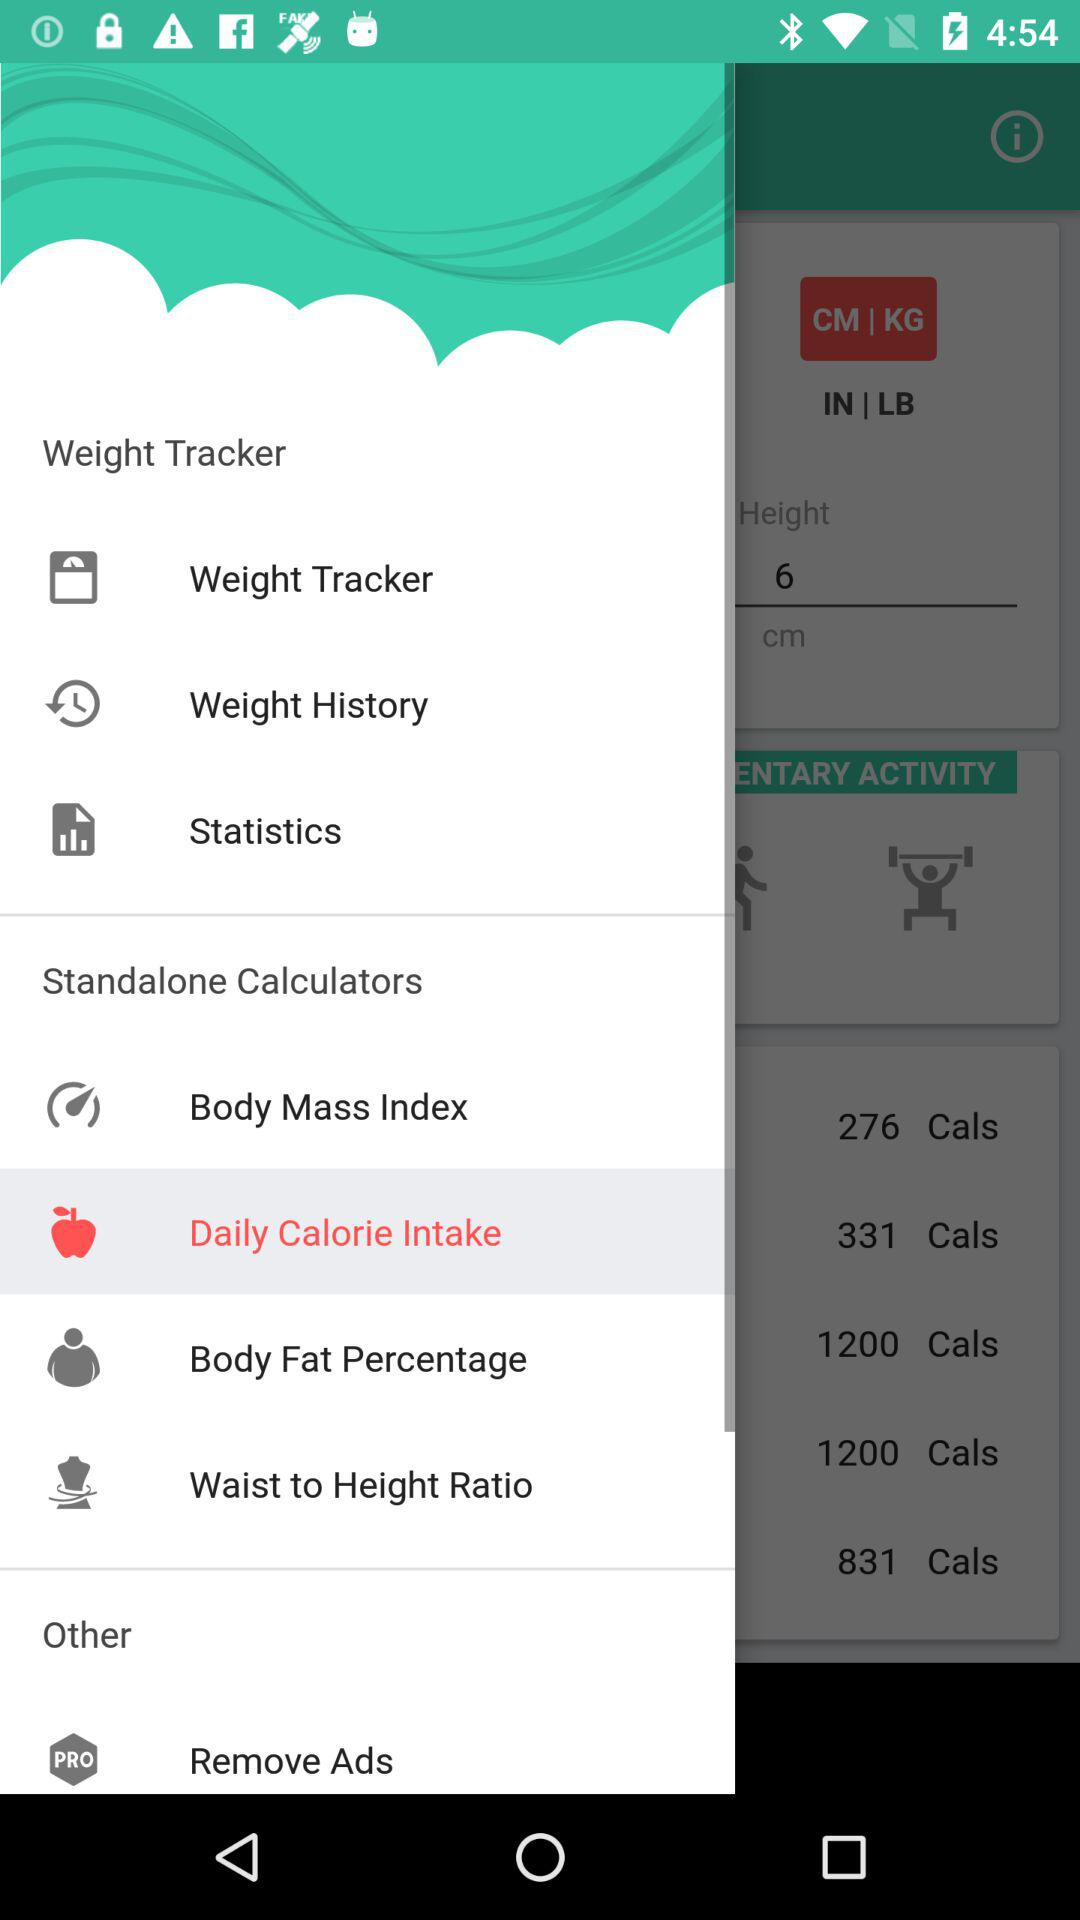What is the application name? The application name is "Weight Tracker". 